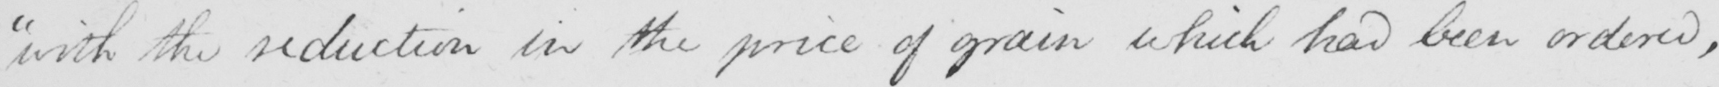What does this handwritten line say? " with the reduction in the price of grain which had been ordered , 